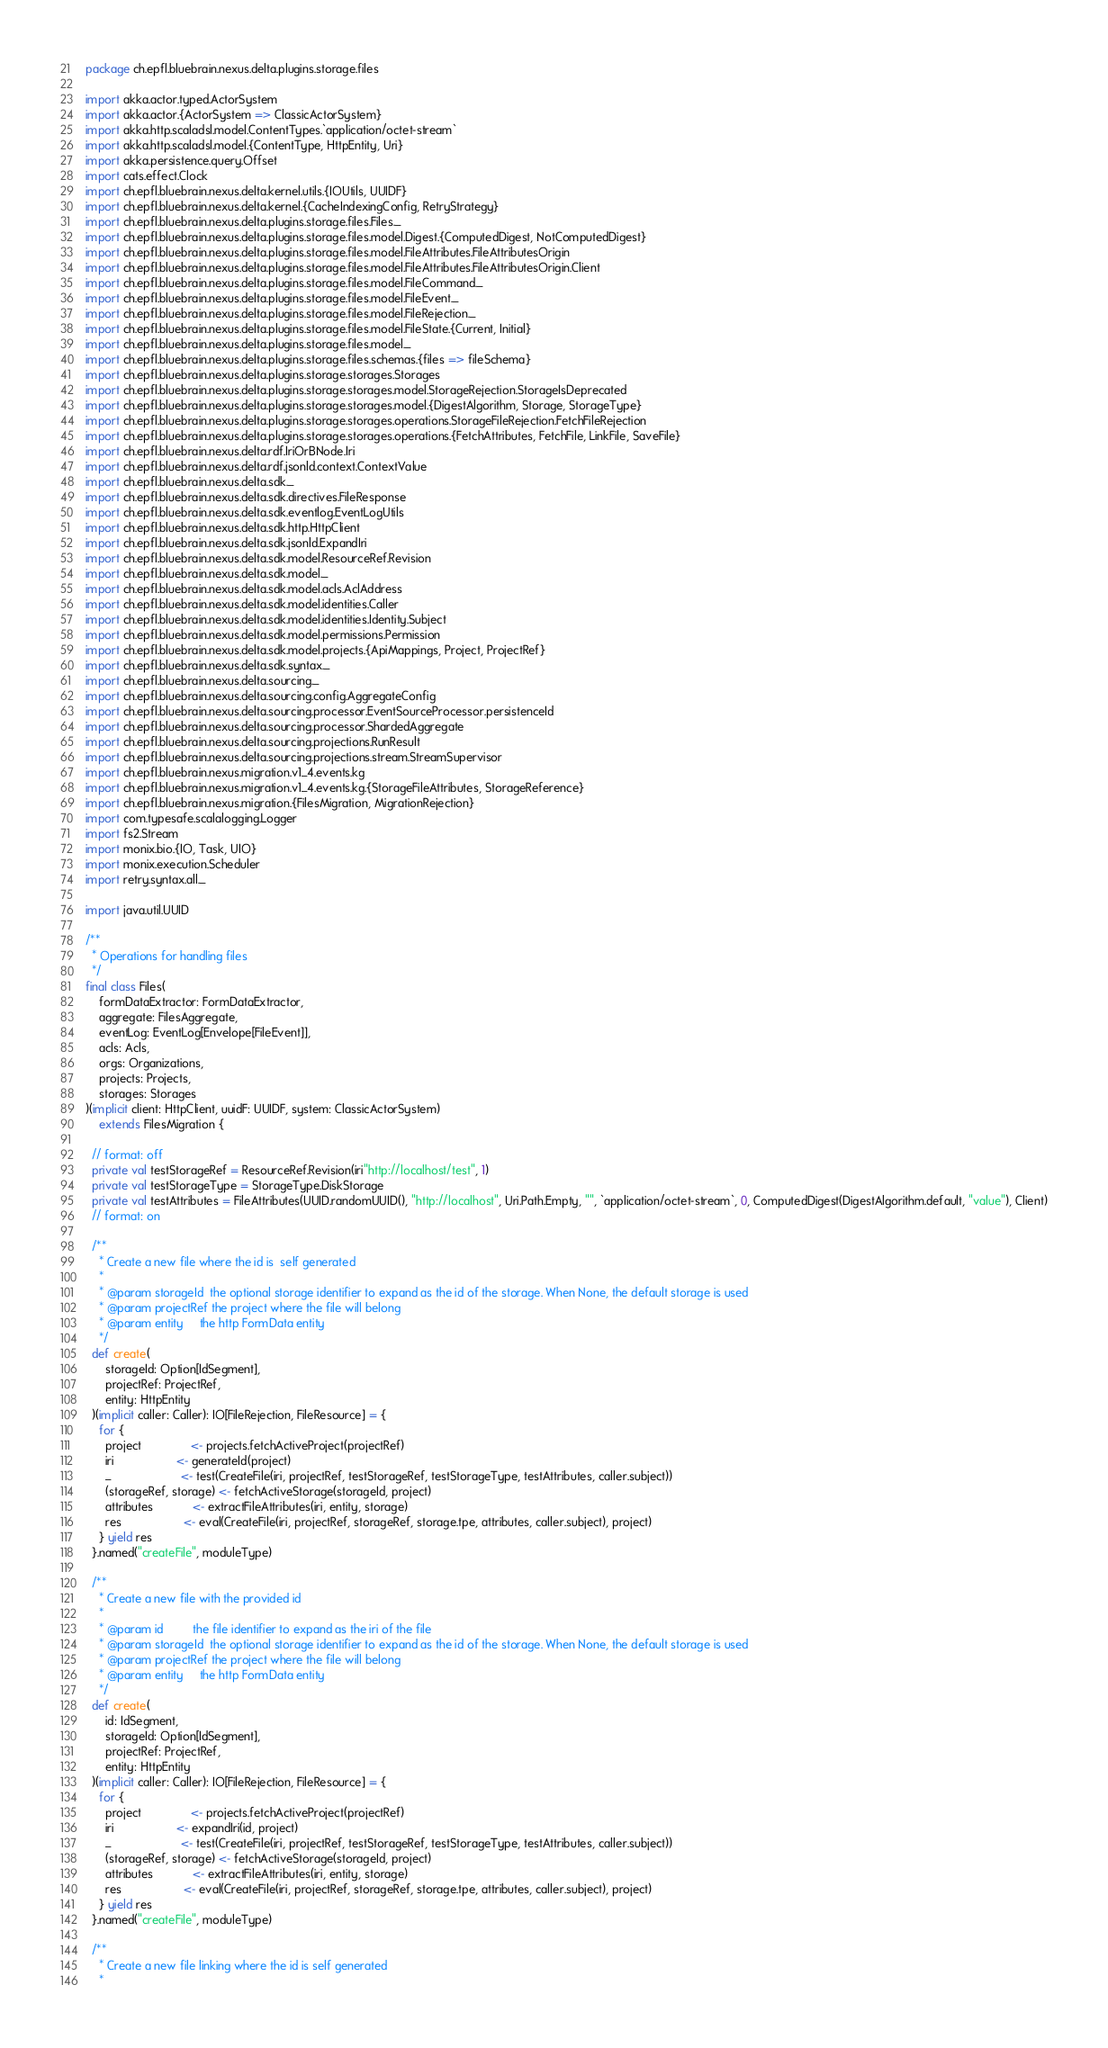<code> <loc_0><loc_0><loc_500><loc_500><_Scala_>package ch.epfl.bluebrain.nexus.delta.plugins.storage.files

import akka.actor.typed.ActorSystem
import akka.actor.{ActorSystem => ClassicActorSystem}
import akka.http.scaladsl.model.ContentTypes.`application/octet-stream`
import akka.http.scaladsl.model.{ContentType, HttpEntity, Uri}
import akka.persistence.query.Offset
import cats.effect.Clock
import ch.epfl.bluebrain.nexus.delta.kernel.utils.{IOUtils, UUIDF}
import ch.epfl.bluebrain.nexus.delta.kernel.{CacheIndexingConfig, RetryStrategy}
import ch.epfl.bluebrain.nexus.delta.plugins.storage.files.Files._
import ch.epfl.bluebrain.nexus.delta.plugins.storage.files.model.Digest.{ComputedDigest, NotComputedDigest}
import ch.epfl.bluebrain.nexus.delta.plugins.storage.files.model.FileAttributes.FileAttributesOrigin
import ch.epfl.bluebrain.nexus.delta.plugins.storage.files.model.FileAttributes.FileAttributesOrigin.Client
import ch.epfl.bluebrain.nexus.delta.plugins.storage.files.model.FileCommand._
import ch.epfl.bluebrain.nexus.delta.plugins.storage.files.model.FileEvent._
import ch.epfl.bluebrain.nexus.delta.plugins.storage.files.model.FileRejection._
import ch.epfl.bluebrain.nexus.delta.plugins.storage.files.model.FileState.{Current, Initial}
import ch.epfl.bluebrain.nexus.delta.plugins.storage.files.model._
import ch.epfl.bluebrain.nexus.delta.plugins.storage.files.schemas.{files => fileSchema}
import ch.epfl.bluebrain.nexus.delta.plugins.storage.storages.Storages
import ch.epfl.bluebrain.nexus.delta.plugins.storage.storages.model.StorageRejection.StorageIsDeprecated
import ch.epfl.bluebrain.nexus.delta.plugins.storage.storages.model.{DigestAlgorithm, Storage, StorageType}
import ch.epfl.bluebrain.nexus.delta.plugins.storage.storages.operations.StorageFileRejection.FetchFileRejection
import ch.epfl.bluebrain.nexus.delta.plugins.storage.storages.operations.{FetchAttributes, FetchFile, LinkFile, SaveFile}
import ch.epfl.bluebrain.nexus.delta.rdf.IriOrBNode.Iri
import ch.epfl.bluebrain.nexus.delta.rdf.jsonld.context.ContextValue
import ch.epfl.bluebrain.nexus.delta.sdk._
import ch.epfl.bluebrain.nexus.delta.sdk.directives.FileResponse
import ch.epfl.bluebrain.nexus.delta.sdk.eventlog.EventLogUtils
import ch.epfl.bluebrain.nexus.delta.sdk.http.HttpClient
import ch.epfl.bluebrain.nexus.delta.sdk.jsonld.ExpandIri
import ch.epfl.bluebrain.nexus.delta.sdk.model.ResourceRef.Revision
import ch.epfl.bluebrain.nexus.delta.sdk.model._
import ch.epfl.bluebrain.nexus.delta.sdk.model.acls.AclAddress
import ch.epfl.bluebrain.nexus.delta.sdk.model.identities.Caller
import ch.epfl.bluebrain.nexus.delta.sdk.model.identities.Identity.Subject
import ch.epfl.bluebrain.nexus.delta.sdk.model.permissions.Permission
import ch.epfl.bluebrain.nexus.delta.sdk.model.projects.{ApiMappings, Project, ProjectRef}
import ch.epfl.bluebrain.nexus.delta.sdk.syntax._
import ch.epfl.bluebrain.nexus.delta.sourcing._
import ch.epfl.bluebrain.nexus.delta.sourcing.config.AggregateConfig
import ch.epfl.bluebrain.nexus.delta.sourcing.processor.EventSourceProcessor.persistenceId
import ch.epfl.bluebrain.nexus.delta.sourcing.processor.ShardedAggregate
import ch.epfl.bluebrain.nexus.delta.sourcing.projections.RunResult
import ch.epfl.bluebrain.nexus.delta.sourcing.projections.stream.StreamSupervisor
import ch.epfl.bluebrain.nexus.migration.v1_4.events.kg
import ch.epfl.bluebrain.nexus.migration.v1_4.events.kg.{StorageFileAttributes, StorageReference}
import ch.epfl.bluebrain.nexus.migration.{FilesMigration, MigrationRejection}
import com.typesafe.scalalogging.Logger
import fs2.Stream
import monix.bio.{IO, Task, UIO}
import monix.execution.Scheduler
import retry.syntax.all._

import java.util.UUID

/**
  * Operations for handling files
  */
final class Files(
    formDataExtractor: FormDataExtractor,
    aggregate: FilesAggregate,
    eventLog: EventLog[Envelope[FileEvent]],
    acls: Acls,
    orgs: Organizations,
    projects: Projects,
    storages: Storages
)(implicit client: HttpClient, uuidF: UUIDF, system: ClassicActorSystem)
    extends FilesMigration {

  // format: off
  private val testStorageRef = ResourceRef.Revision(iri"http://localhost/test", 1)
  private val testStorageType = StorageType.DiskStorage
  private val testAttributes = FileAttributes(UUID.randomUUID(), "http://localhost", Uri.Path.Empty, "", `application/octet-stream`, 0, ComputedDigest(DigestAlgorithm.default, "value"), Client)
  // format: on

  /**
    * Create a new file where the id is  self generated
    *
    * @param storageId  the optional storage identifier to expand as the id of the storage. When None, the default storage is used
    * @param projectRef the project where the file will belong
    * @param entity     the http FormData entity
    */
  def create(
      storageId: Option[IdSegment],
      projectRef: ProjectRef,
      entity: HttpEntity
  )(implicit caller: Caller): IO[FileRejection, FileResource] = {
    for {
      project               <- projects.fetchActiveProject(projectRef)
      iri                   <- generateId(project)
      _                     <- test(CreateFile(iri, projectRef, testStorageRef, testStorageType, testAttributes, caller.subject))
      (storageRef, storage) <- fetchActiveStorage(storageId, project)
      attributes            <- extractFileAttributes(iri, entity, storage)
      res                   <- eval(CreateFile(iri, projectRef, storageRef, storage.tpe, attributes, caller.subject), project)
    } yield res
  }.named("createFile", moduleType)

  /**
    * Create a new file with the provided id
    *
    * @param id         the file identifier to expand as the iri of the file
    * @param storageId  the optional storage identifier to expand as the id of the storage. When None, the default storage is used
    * @param projectRef the project where the file will belong
    * @param entity     the http FormData entity
    */
  def create(
      id: IdSegment,
      storageId: Option[IdSegment],
      projectRef: ProjectRef,
      entity: HttpEntity
  )(implicit caller: Caller): IO[FileRejection, FileResource] = {
    for {
      project               <- projects.fetchActiveProject(projectRef)
      iri                   <- expandIri(id, project)
      _                     <- test(CreateFile(iri, projectRef, testStorageRef, testStorageType, testAttributes, caller.subject))
      (storageRef, storage) <- fetchActiveStorage(storageId, project)
      attributes            <- extractFileAttributes(iri, entity, storage)
      res                   <- eval(CreateFile(iri, projectRef, storageRef, storage.tpe, attributes, caller.subject), project)
    } yield res
  }.named("createFile", moduleType)

  /**
    * Create a new file linking where the id is self generated
    *</code> 